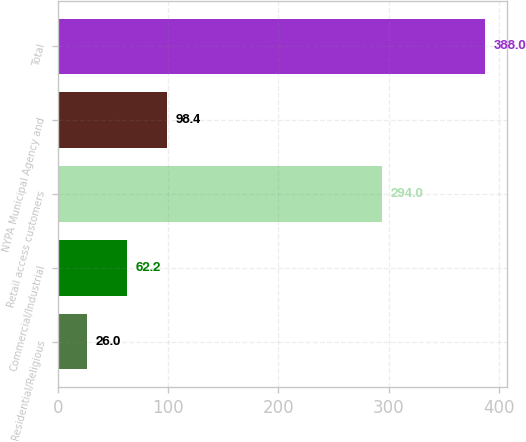Convert chart. <chart><loc_0><loc_0><loc_500><loc_500><bar_chart><fcel>Residential/Religious<fcel>Commercial/Industrial<fcel>Retail access customers<fcel>NYPA Municipal Agency and<fcel>Total<nl><fcel>26<fcel>62.2<fcel>294<fcel>98.4<fcel>388<nl></chart> 